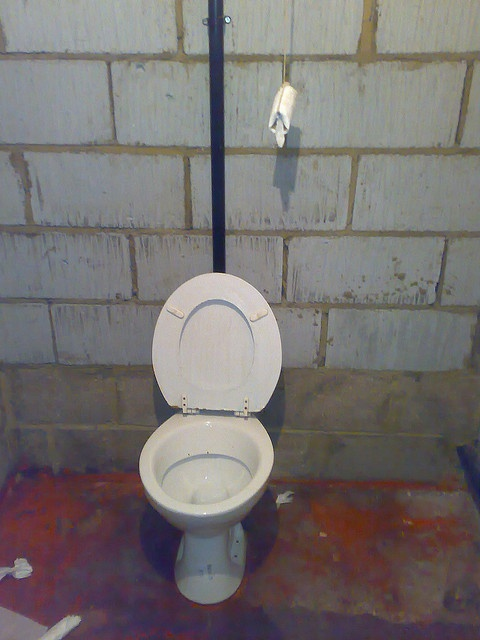Describe the objects in this image and their specific colors. I can see a toilet in darkgray, gray, and lightgray tones in this image. 